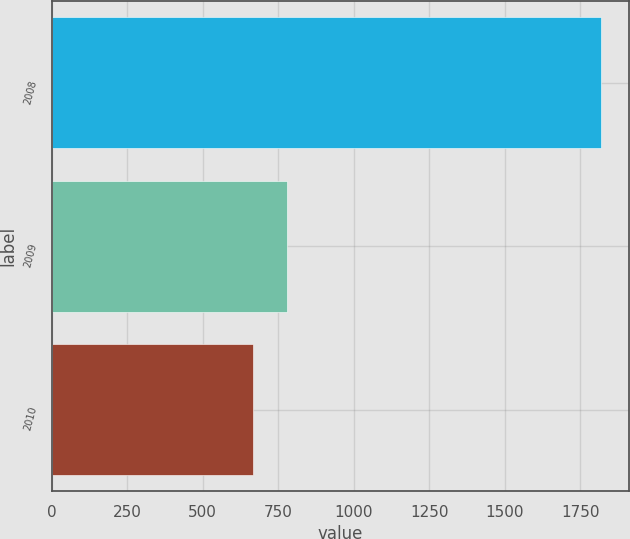Convert chart to OTSL. <chart><loc_0><loc_0><loc_500><loc_500><bar_chart><fcel>2008<fcel>2009<fcel>2010<nl><fcel>1819<fcel>780.4<fcel>665<nl></chart> 